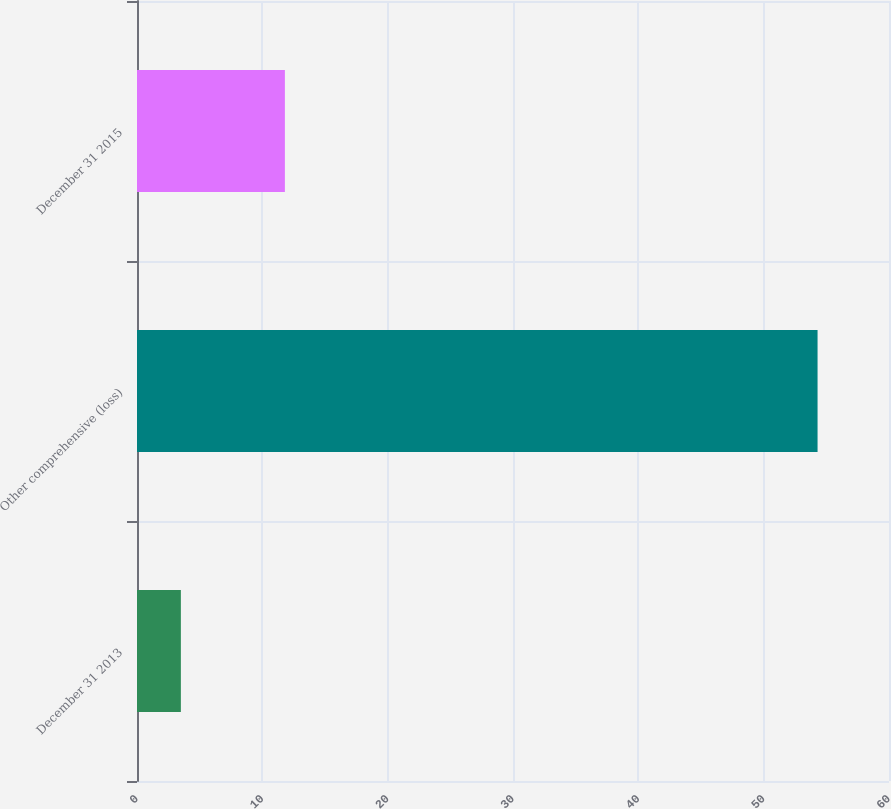Convert chart. <chart><loc_0><loc_0><loc_500><loc_500><bar_chart><fcel>December 31 2013<fcel>Other comprehensive (loss)<fcel>December 31 2015<nl><fcel>3.5<fcel>54.3<fcel>11.8<nl></chart> 